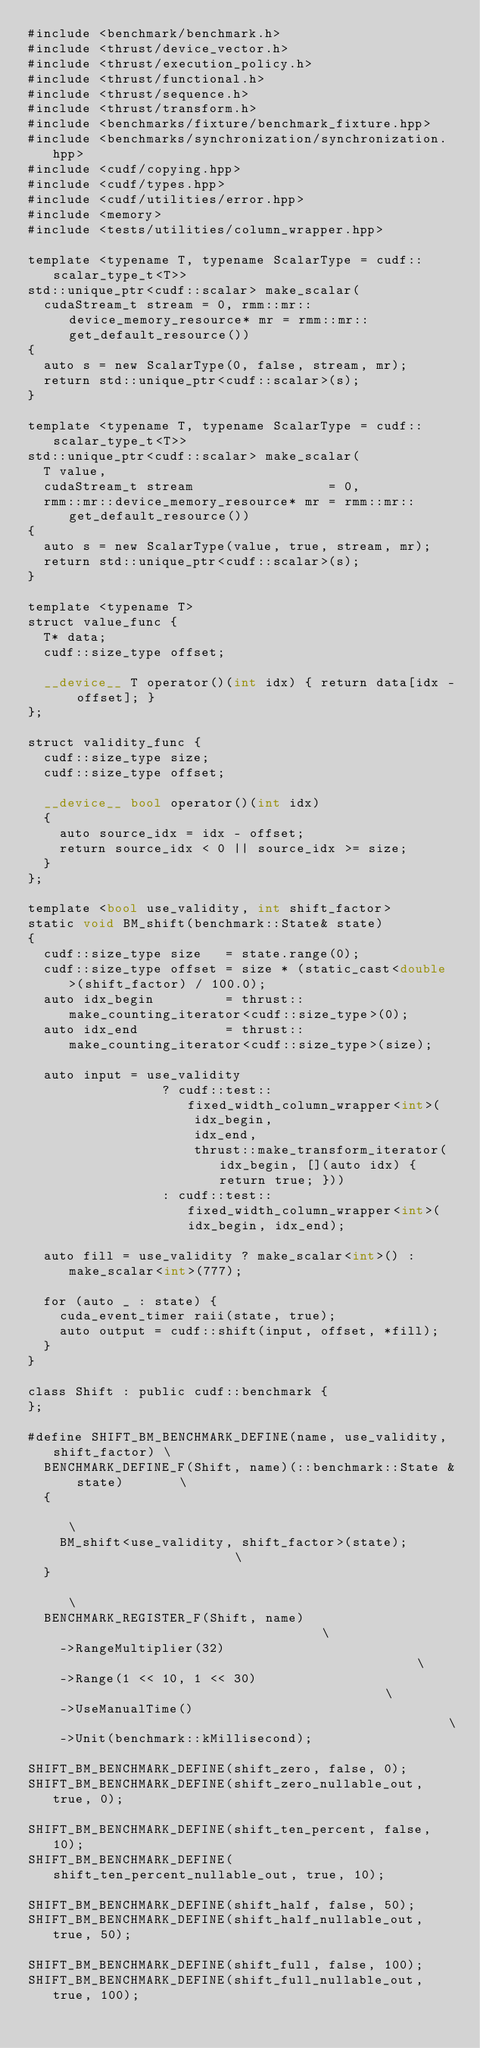<code> <loc_0><loc_0><loc_500><loc_500><_Cuda_>#include <benchmark/benchmark.h>
#include <thrust/device_vector.h>
#include <thrust/execution_policy.h>
#include <thrust/functional.h>
#include <thrust/sequence.h>
#include <thrust/transform.h>
#include <benchmarks/fixture/benchmark_fixture.hpp>
#include <benchmarks/synchronization/synchronization.hpp>
#include <cudf/copying.hpp>
#include <cudf/types.hpp>
#include <cudf/utilities/error.hpp>
#include <memory>
#include <tests/utilities/column_wrapper.hpp>

template <typename T, typename ScalarType = cudf::scalar_type_t<T>>
std::unique_ptr<cudf::scalar> make_scalar(
  cudaStream_t stream = 0, rmm::mr::device_memory_resource* mr = rmm::mr::get_default_resource())
{
  auto s = new ScalarType(0, false, stream, mr);
  return std::unique_ptr<cudf::scalar>(s);
}

template <typename T, typename ScalarType = cudf::scalar_type_t<T>>
std::unique_ptr<cudf::scalar> make_scalar(
  T value,
  cudaStream_t stream                 = 0,
  rmm::mr::device_memory_resource* mr = rmm::mr::get_default_resource())
{
  auto s = new ScalarType(value, true, stream, mr);
  return std::unique_ptr<cudf::scalar>(s);
}

template <typename T>
struct value_func {
  T* data;
  cudf::size_type offset;

  __device__ T operator()(int idx) { return data[idx - offset]; }
};

struct validity_func {
  cudf::size_type size;
  cudf::size_type offset;

  __device__ bool operator()(int idx)
  {
    auto source_idx = idx - offset;
    return source_idx < 0 || source_idx >= size;
  }
};

template <bool use_validity, int shift_factor>
static void BM_shift(benchmark::State& state)
{
  cudf::size_type size   = state.range(0);
  cudf::size_type offset = size * (static_cast<double>(shift_factor) / 100.0);
  auto idx_begin         = thrust::make_counting_iterator<cudf::size_type>(0);
  auto idx_end           = thrust::make_counting_iterator<cudf::size_type>(size);

  auto input = use_validity
                 ? cudf::test::fixed_width_column_wrapper<int>(
                     idx_begin,
                     idx_end,
                     thrust::make_transform_iterator(idx_begin, [](auto idx) { return true; }))
                 : cudf::test::fixed_width_column_wrapper<int>(idx_begin, idx_end);

  auto fill = use_validity ? make_scalar<int>() : make_scalar<int>(777);

  for (auto _ : state) {
    cuda_event_timer raii(state, true);
    auto output = cudf::shift(input, offset, *fill);
  }
}

class Shift : public cudf::benchmark {
};

#define SHIFT_BM_BENCHMARK_DEFINE(name, use_validity, shift_factor) \
  BENCHMARK_DEFINE_F(Shift, name)(::benchmark::State & state)       \
  {                                                                 \
    BM_shift<use_validity, shift_factor>(state);                    \
  }                                                                 \
  BENCHMARK_REGISTER_F(Shift, name)                                 \
    ->RangeMultiplier(32)                                           \
    ->Range(1 << 10, 1 << 30)                                       \
    ->UseManualTime()                                               \
    ->Unit(benchmark::kMillisecond);

SHIFT_BM_BENCHMARK_DEFINE(shift_zero, false, 0);
SHIFT_BM_BENCHMARK_DEFINE(shift_zero_nullable_out, true, 0);

SHIFT_BM_BENCHMARK_DEFINE(shift_ten_percent, false, 10);
SHIFT_BM_BENCHMARK_DEFINE(shift_ten_percent_nullable_out, true, 10);

SHIFT_BM_BENCHMARK_DEFINE(shift_half, false, 50);
SHIFT_BM_BENCHMARK_DEFINE(shift_half_nullable_out, true, 50);

SHIFT_BM_BENCHMARK_DEFINE(shift_full, false, 100);
SHIFT_BM_BENCHMARK_DEFINE(shift_full_nullable_out, true, 100);
</code> 